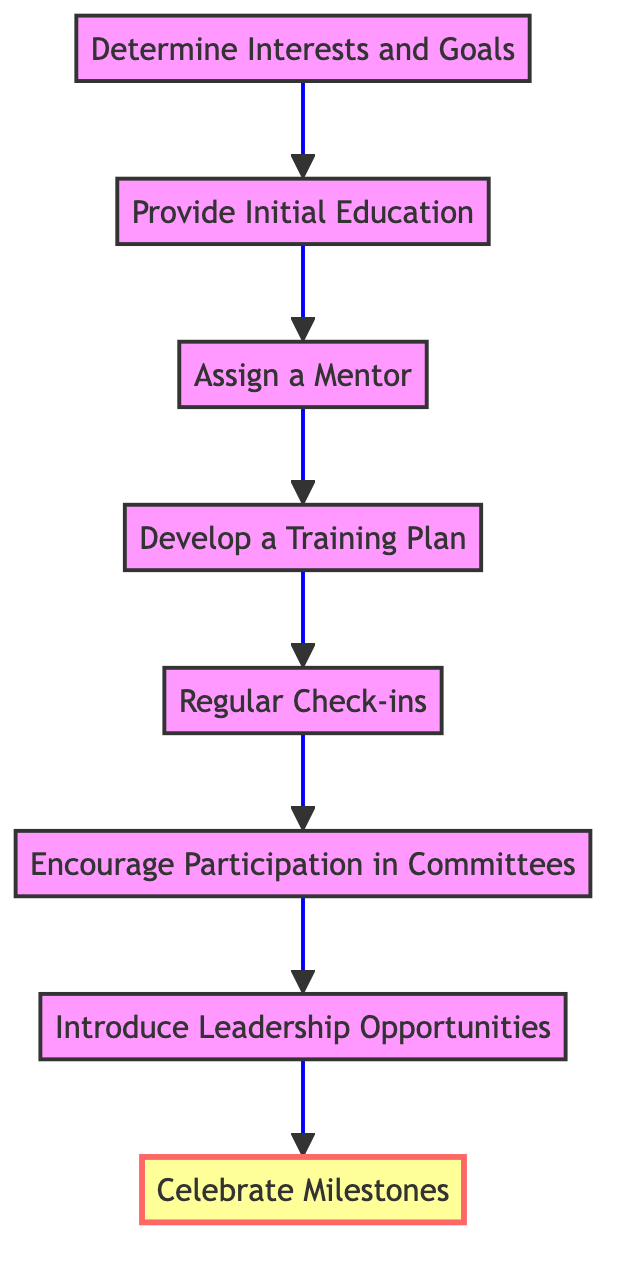What is the first step in the mentoring process? The flow chart begins with the node "Determine Interests and Goals," which indicates that this is the first step in the process of mentoring new union members.
Answer: Determine Interests and Goals How many total steps are there in the mentoring process? By counting the nodes in the flow chart, there are eight steps from "Determine Interests and Goals" to "Celebrate Milestones."
Answer: Eight What is paired with "Assign a Mentor" in the flow? The flow indicates that "Assign a Mentor" is immediately followed by "Develop a Training Plan," showing the relationship between these two steps.
Answer: Develop a Training Plan Which step involves encouraging new members to participate in union activities? The flow chart specifies "Encourage Participation in Committees" as the step focused on involving new members in union activities, following regular check-ins.
Answer: Encourage Participation in Committees What is the last step in the mentoring process? According to the flow chart, the final step of the process is labeled "Celebrate Milestones," signifying the conclusion of the mentoring journey.
Answer: Celebrate Milestones What two nodes directly precede "Introduce Leadership Opportunities"? The flow shows that "Encourage Participation in Committees" and "Introduce Leadership Opportunities" are two consecutive steps, thus directly preceding this node in the process.
Answer: Encourage Participation in Committees, Develop a Training Plan Which step highlights the achievements of new members? The chart indicates that "Celebrate Milestones" is the step that recognizes and celebrates the achievements of new members, making it clear what this stage entails.
Answer: Celebrate Milestones How does the process begin with understanding new members? The initial node in the chart, "Determine Interests and Goals," emphasizes the importance of understanding new members' interests and career goals as the foundational step.
Answer: Determine Interests and Goals What step comes after "Regular Check-ins"? The flow chart shows "Encourage Participation in Committees" as the next step following regular check-ins, allowing for engagement in union activities.
Answer: Encourage Participation in Committees 